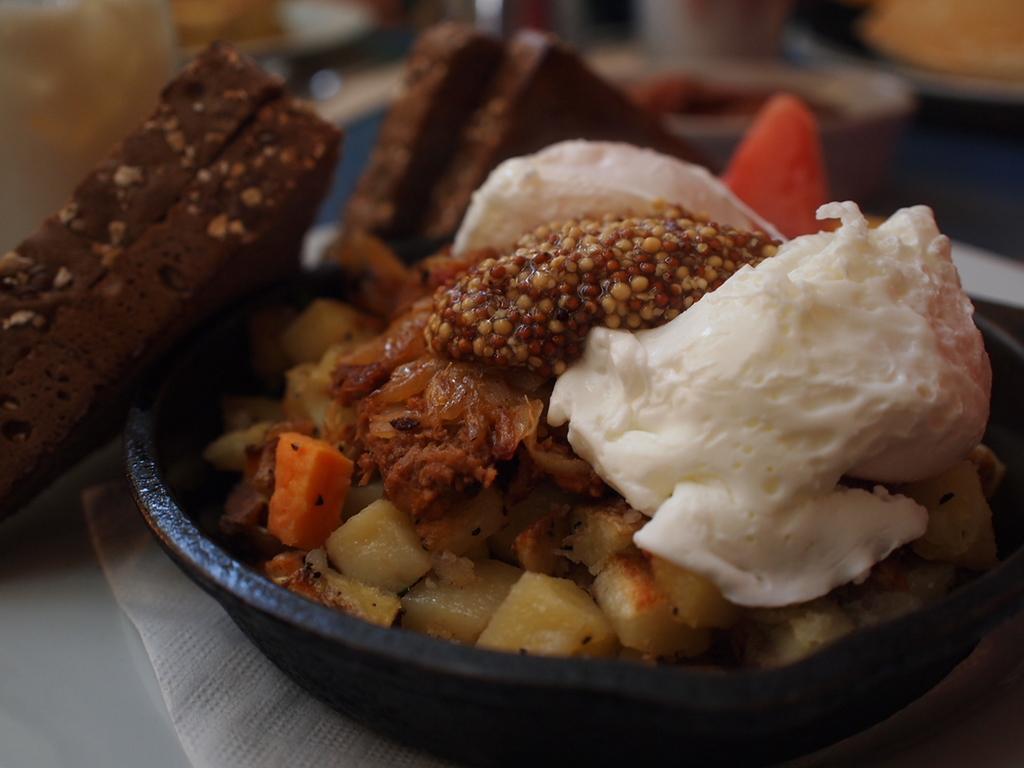Could you give a brief overview of what you see in this image? In this image, I can see a bowl, which contains food. I think I can see two pieces of cake. This is a tissue paper. This looks like a table, which is white in color. The background looks blurry. 